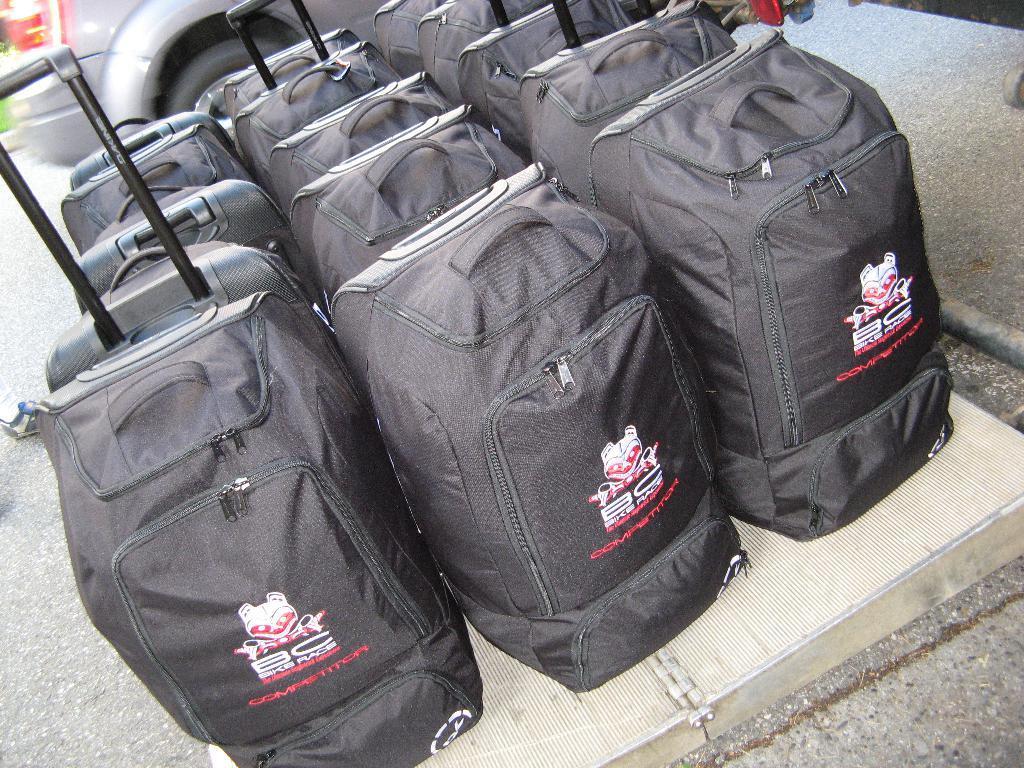How would you summarize this image in a sentence or two? This black luggage bags are highlighted in this picture. Backside of this luggage bags there is a vehicle. 